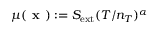Convert formula to latex. <formula><loc_0><loc_0><loc_500><loc_500>\mu ( x ) \colon = S _ { e x t } ( T / n _ { T } ) ^ { \alpha }</formula> 